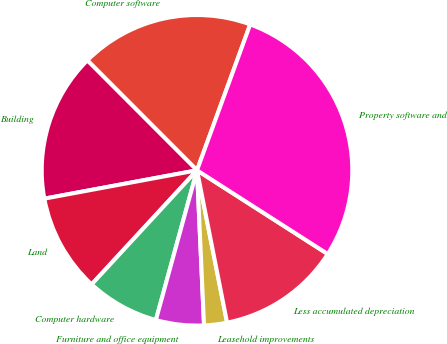Convert chart to OTSL. <chart><loc_0><loc_0><loc_500><loc_500><pie_chart><fcel>Computer software<fcel>Building<fcel>Land<fcel>Computer hardware<fcel>Furniture and office equipment<fcel>Leasehold improvements<fcel>Less accumulated depreciation<fcel>Property software and<nl><fcel>18.05%<fcel>15.44%<fcel>10.21%<fcel>7.6%<fcel>4.99%<fcel>2.38%<fcel>12.83%<fcel>28.5%<nl></chart> 